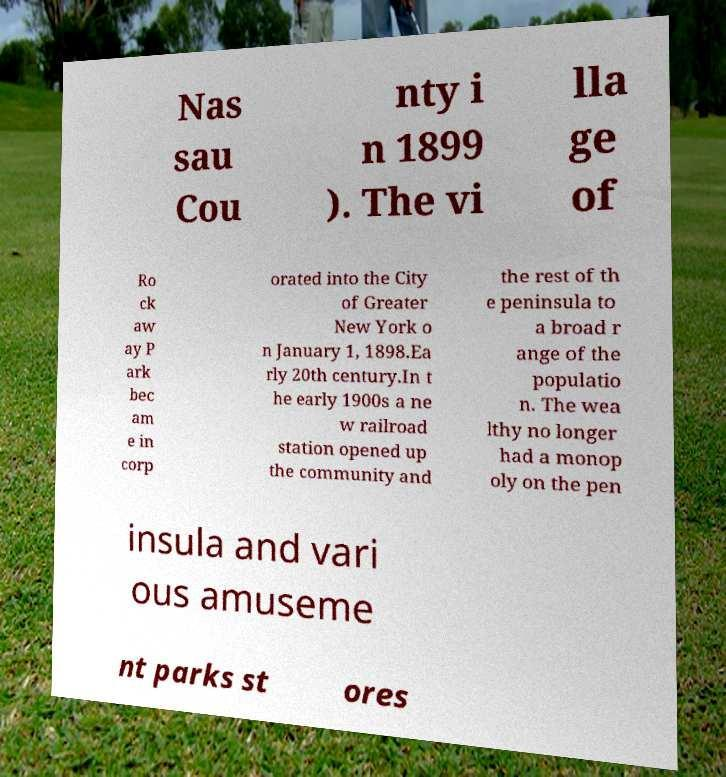Please read and relay the text visible in this image. What does it say? Nas sau Cou nty i n 1899 ). The vi lla ge of Ro ck aw ay P ark bec am e in corp orated into the City of Greater New York o n January 1, 1898.Ea rly 20th century.In t he early 1900s a ne w railroad station opened up the community and the rest of th e peninsula to a broad r ange of the populatio n. The wea lthy no longer had a monop oly on the pen insula and vari ous amuseme nt parks st ores 